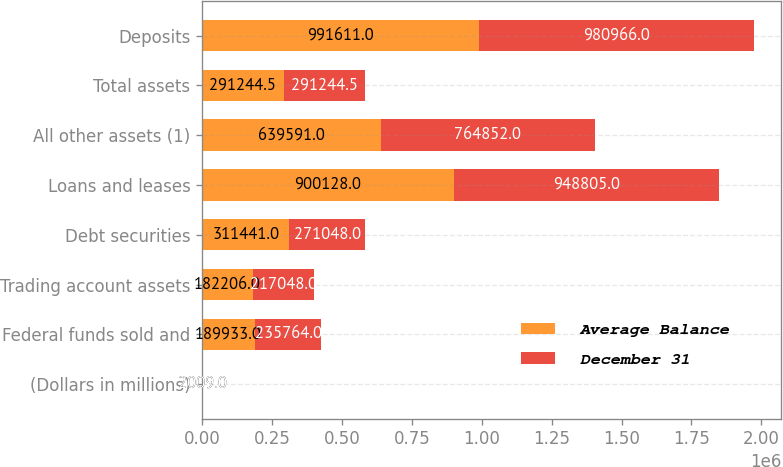Convert chart to OTSL. <chart><loc_0><loc_0><loc_500><loc_500><stacked_bar_chart><ecel><fcel>(Dollars in millions)<fcel>Federal funds sold and<fcel>Trading account assets<fcel>Debt securities<fcel>Loans and leases<fcel>All other assets (1)<fcel>Total assets<fcel>Deposits<nl><fcel>Average Balance<fcel>2009<fcel>189933<fcel>182206<fcel>311441<fcel>900128<fcel>639591<fcel>291244<fcel>991611<nl><fcel>December 31<fcel>2009<fcel>235764<fcel>217048<fcel>271048<fcel>948805<fcel>764852<fcel>291244<fcel>980966<nl></chart> 